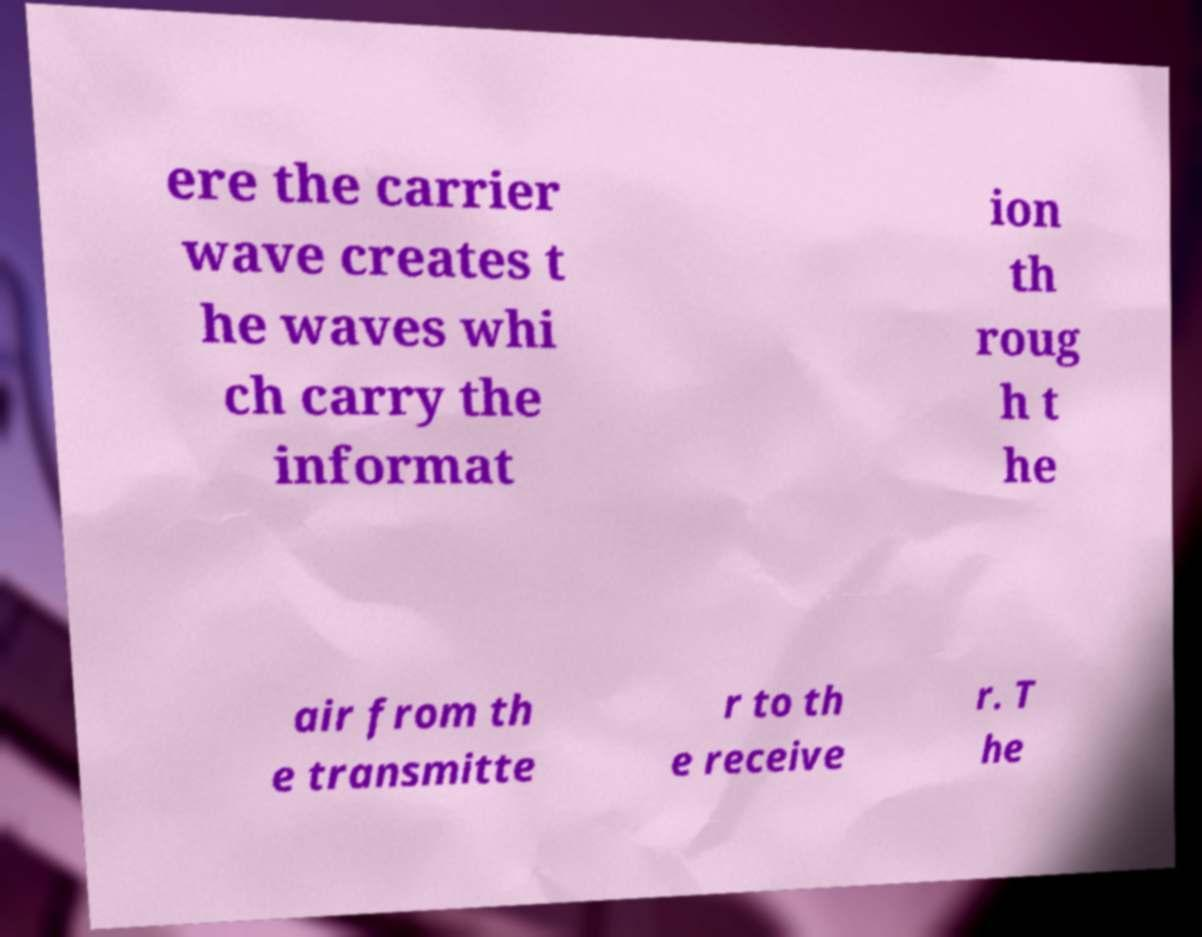There's text embedded in this image that I need extracted. Can you transcribe it verbatim? ere the carrier wave creates t he waves whi ch carry the informat ion th roug h t he air from th e transmitte r to th e receive r. T he 